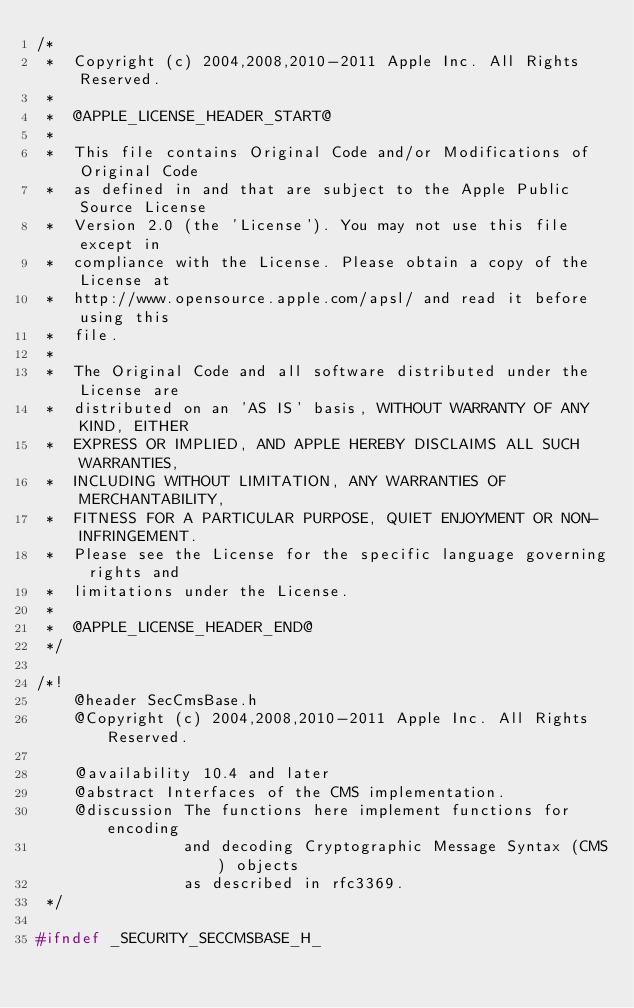<code> <loc_0><loc_0><loc_500><loc_500><_C_>/*
 *  Copyright (c) 2004,2008,2010-2011 Apple Inc. All Rights Reserved.
 *
 *  @APPLE_LICENSE_HEADER_START@
 *  
 *  This file contains Original Code and/or Modifications of Original Code
 *  as defined in and that are subject to the Apple Public Source License
 *  Version 2.0 (the 'License'). You may not use this file except in
 *  compliance with the License. Please obtain a copy of the License at
 *  http://www.opensource.apple.com/apsl/ and read it before using this
 *  file.
 *  
 *  The Original Code and all software distributed under the License are
 *  distributed on an 'AS IS' basis, WITHOUT WARRANTY OF ANY KIND, EITHER
 *  EXPRESS OR IMPLIED, AND APPLE HEREBY DISCLAIMS ALL SUCH WARRANTIES,
 *  INCLUDING WITHOUT LIMITATION, ANY WARRANTIES OF MERCHANTABILITY,
 *  FITNESS FOR A PARTICULAR PURPOSE, QUIET ENJOYMENT OR NON-INFRINGEMENT.
 *  Please see the License for the specific language governing rights and
 *  limitations under the License.
 *  
 *  @APPLE_LICENSE_HEADER_END@
 */

/*!
    @header SecCmsBase.h
    @Copyright (c) 2004,2008,2010-2011 Apple Inc. All Rights Reserved.

    @availability 10.4 and later
    @abstract Interfaces of the CMS implementation.
    @discussion The functions here implement functions for encoding
                and decoding Cryptographic Message Syntax (CMS) objects
                as described in rfc3369.
 */

#ifndef _SECURITY_SECCMSBASE_H_</code> 